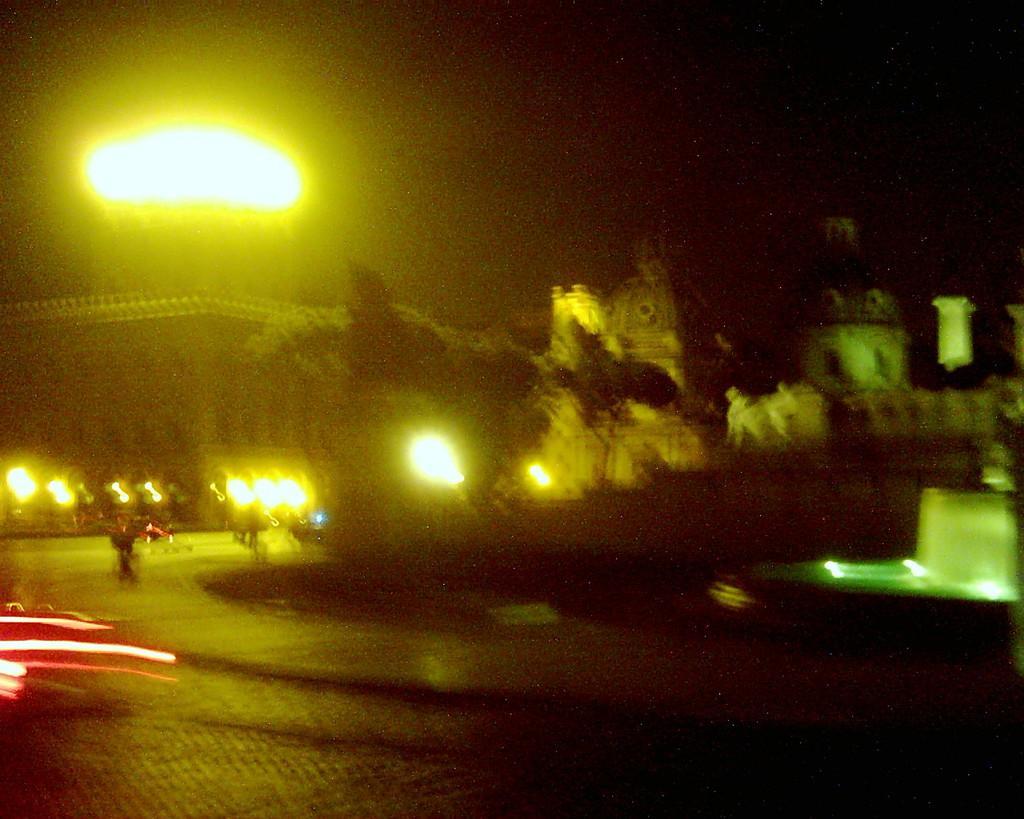Can you describe this image briefly? This is a night view of an image. In this image there are buildings, trees, street lights, fountain and few vehicles on the road. 